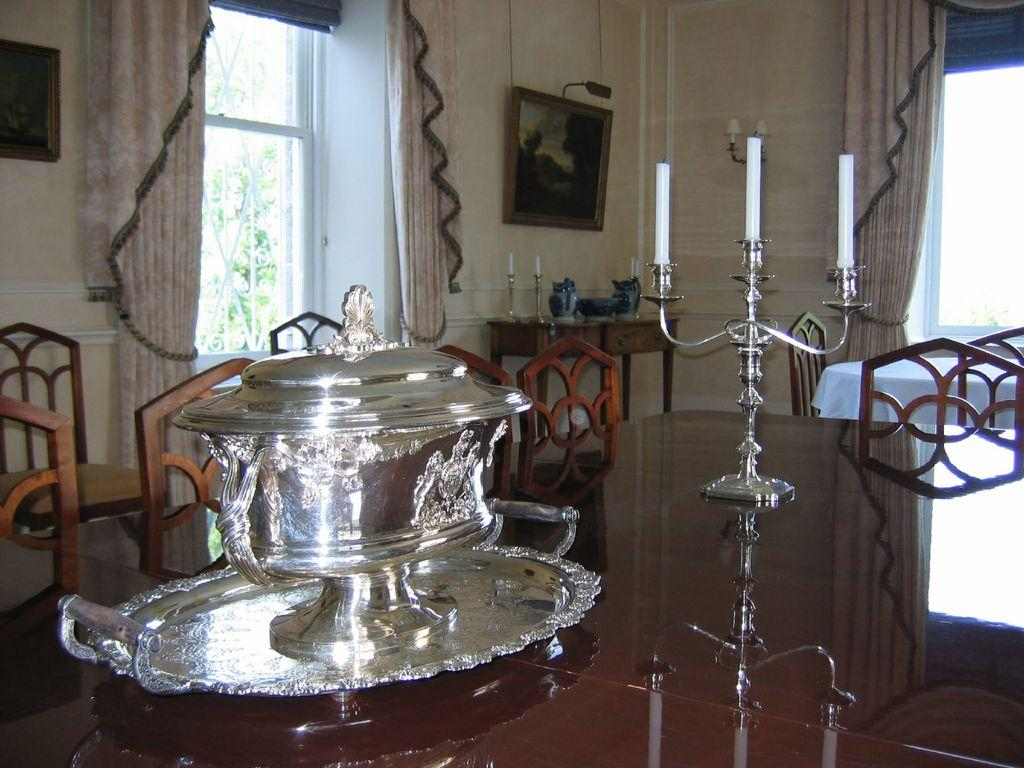What is on the dining table in the image? There is a silver plate and a bowl on the dining table in the image. What else can be seen on the dining table? There are candles on the dining table in the image. What type of furniture is present in the image? There are chairs in the image. Are there any other tables in the image besides the dining table? Yes, there are additional tables in the image. What type of trees can be seen growing on the silver plate in the image? There are no trees present on the silver plate in the image; it is a flat surface. How much sugar is visible in the image? There is no sugar visible in the image. 